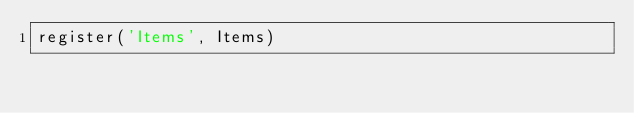<code> <loc_0><loc_0><loc_500><loc_500><_JavaScript_>register('Items', Items)
</code> 